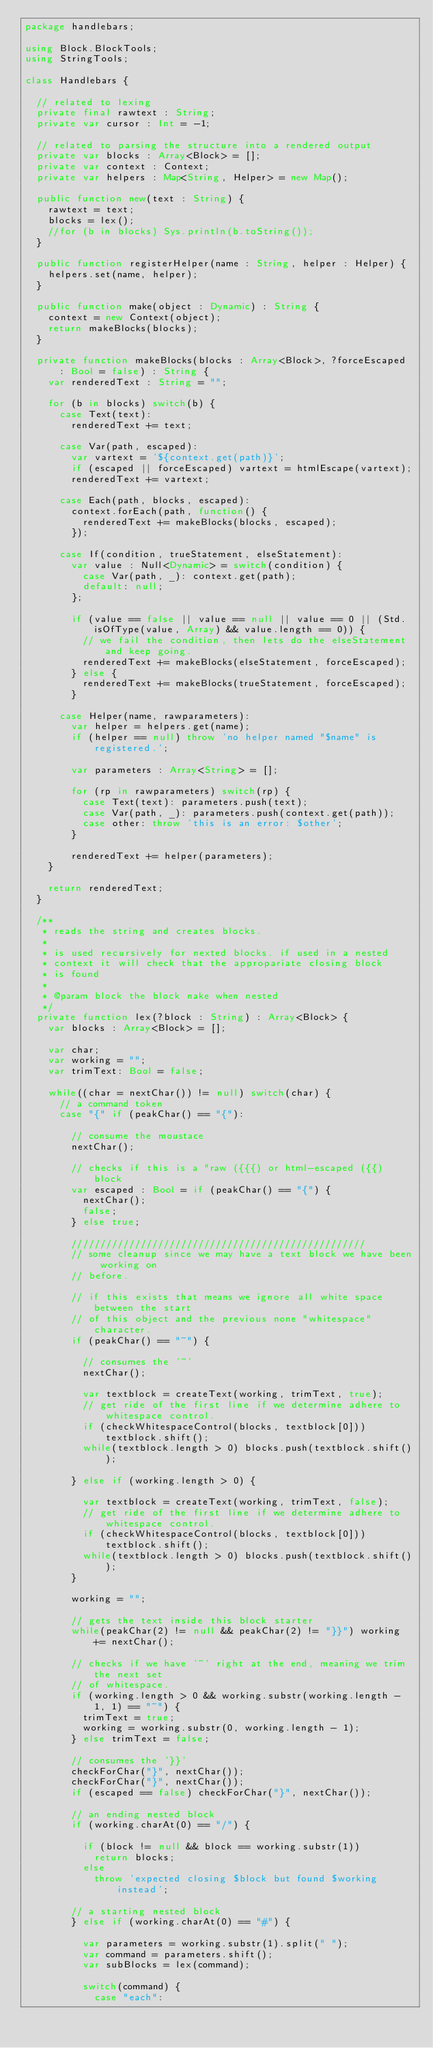Convert code to text. <code><loc_0><loc_0><loc_500><loc_500><_Haxe_>package handlebars;

using Block.BlockTools;
using StringTools;

class Handlebars {

	// related to lexing
	private final rawtext : String;
	private var cursor : Int = -1;

	// related to parsing the structure into a rendered output
	private var blocks : Array<Block> = [];
	private var context : Context;
	private var helpers : Map<String, Helper> = new Map();

	public function new(text : String) {
		rawtext = text;
		blocks = lex();
		//for (b in blocks) Sys.println(b.toString());
	}
	
	public function registerHelper(name : String, helper : Helper) {
		helpers.set(name, helper);
	}

	public function make(object : Dynamic) : String {
		context = new Context(object);
		return makeBlocks(blocks);
	}

	private function makeBlocks(blocks : Array<Block>, ?forceEscaped : Bool = false) : String {
		var renderedText : String = "";

		for (b in blocks) switch(b) {
			case Text(text): 
				renderedText += text;
			
			case Var(path, escaped):
				var vartext = '${context.get(path)}';
				if (escaped || forceEscaped) vartext = htmlEscape(vartext);
				renderedText += vartext;

			case Each(path, blocks, escaped):
				context.forEach(path, function() {
					renderedText += makeBlocks(blocks, escaped);
				});

			case If(condition, trueStatement, elseStatement):
				var value : Null<Dynamic> = switch(condition) {
					case Var(path, _): context.get(path);
					default: null;
				};

				if (value == false || value == null || value == 0 || (Std.isOfType(value, Array) && value.length == 0)) {
					// we fail the condition, then lets do the elseStatement and keep going.
					renderedText += makeBlocks(elseStatement, forceEscaped);
				} else {
					renderedText += makeBlocks(trueStatement, forceEscaped);
				}

			case Helper(name, rawparameters):
				var helper = helpers.get(name);
				if (helper == null) throw 'no helper named "$name" is registered.';

				var parameters : Array<String> = [];

				for (rp in rawparameters) switch(rp) {
					case Text(text): parameters.push(text);
					case Var(path, _): parameters.push(context.get(path));
					case other: throw 'this is an error: $other';
				}

				renderedText += helper(parameters);
		}

		return renderedText;
	}

	/**
	 * reads the string and creates blocks.
	 *
	 * is used recursively for nexted blocks. if used in a nested
	 * context it will check that the appropariate closing block
	 * is found
	 *
	 * @param block the block nake when nested
	 */
	private function lex(?block : String) : Array<Block> {
		var blocks : Array<Block> = [];

		var char;
		var working = "";
		var trimText: Bool = false;

		while((char = nextChar()) != null) switch(char) {
			// a command token
			case "{" if (peakChar() == "{"):

				// consume the moustace
				nextChar();

				// checks if this is a "raw ({{{) or html-escaped ({{) block
				var escaped : Bool = if (peakChar() == "{") {
					nextChar();
					false;
				} else true;

				///////////////////////////////////////////////////
				// some cleanup since we may have a text block we have been working on
				// before.

				// if this exists that means we ignore all white space between the start
				// of this object and the previous none "whitespace" character.
				if (peakChar() == "~") {

					// consumes the '~'
					nextChar();

					var textblock = createText(working, trimText, true);
					// get ride of the first line if we determine adhere to whitespace control.
					if (checkWhitespaceControl(blocks, textblock[0])) textblock.shift();
					while(textblock.length > 0) blocks.push(textblock.shift());

				} else if (working.length > 0) {
					
					var textblock = createText(working, trimText, false);
					// get ride of the first line if we determine adhere to whitespace control.
					if (checkWhitespaceControl(blocks, textblock[0])) textblock.shift();
					while(textblock.length > 0) blocks.push(textblock.shift());
				}
				
				working = "";

				// gets the text inside this block starter
				while(peakChar(2) != null && peakChar(2) != "}}") working += nextChar();

				// checks if we have '~' right at the end, meaning we trim the next set
				// of whitespace.
				if (working.length > 0 && working.substr(working.length - 1, 1) == "~") { 
					trimText = true;
					working = working.substr(0, working.length - 1);
				} else trimText = false;

				// consumes the '}}'
				checkForChar("}", nextChar());
				checkForChar("}", nextChar());
				if (escaped == false) checkForChar("}", nextChar());

				// an ending nested block
				if (working.charAt(0) == "/") {
					
					if (block != null && block == working.substr(1))
						return blocks;
					else
						throw 'expected closing $block but found $working instead';

				// a starting nested block
				} else if (working.charAt(0) == "#") {

					var parameters = working.substr(1).split(" ");
					var command = parameters.shift();
					var subBlocks = lex(command);

					switch(command) {
						case "each":</code> 